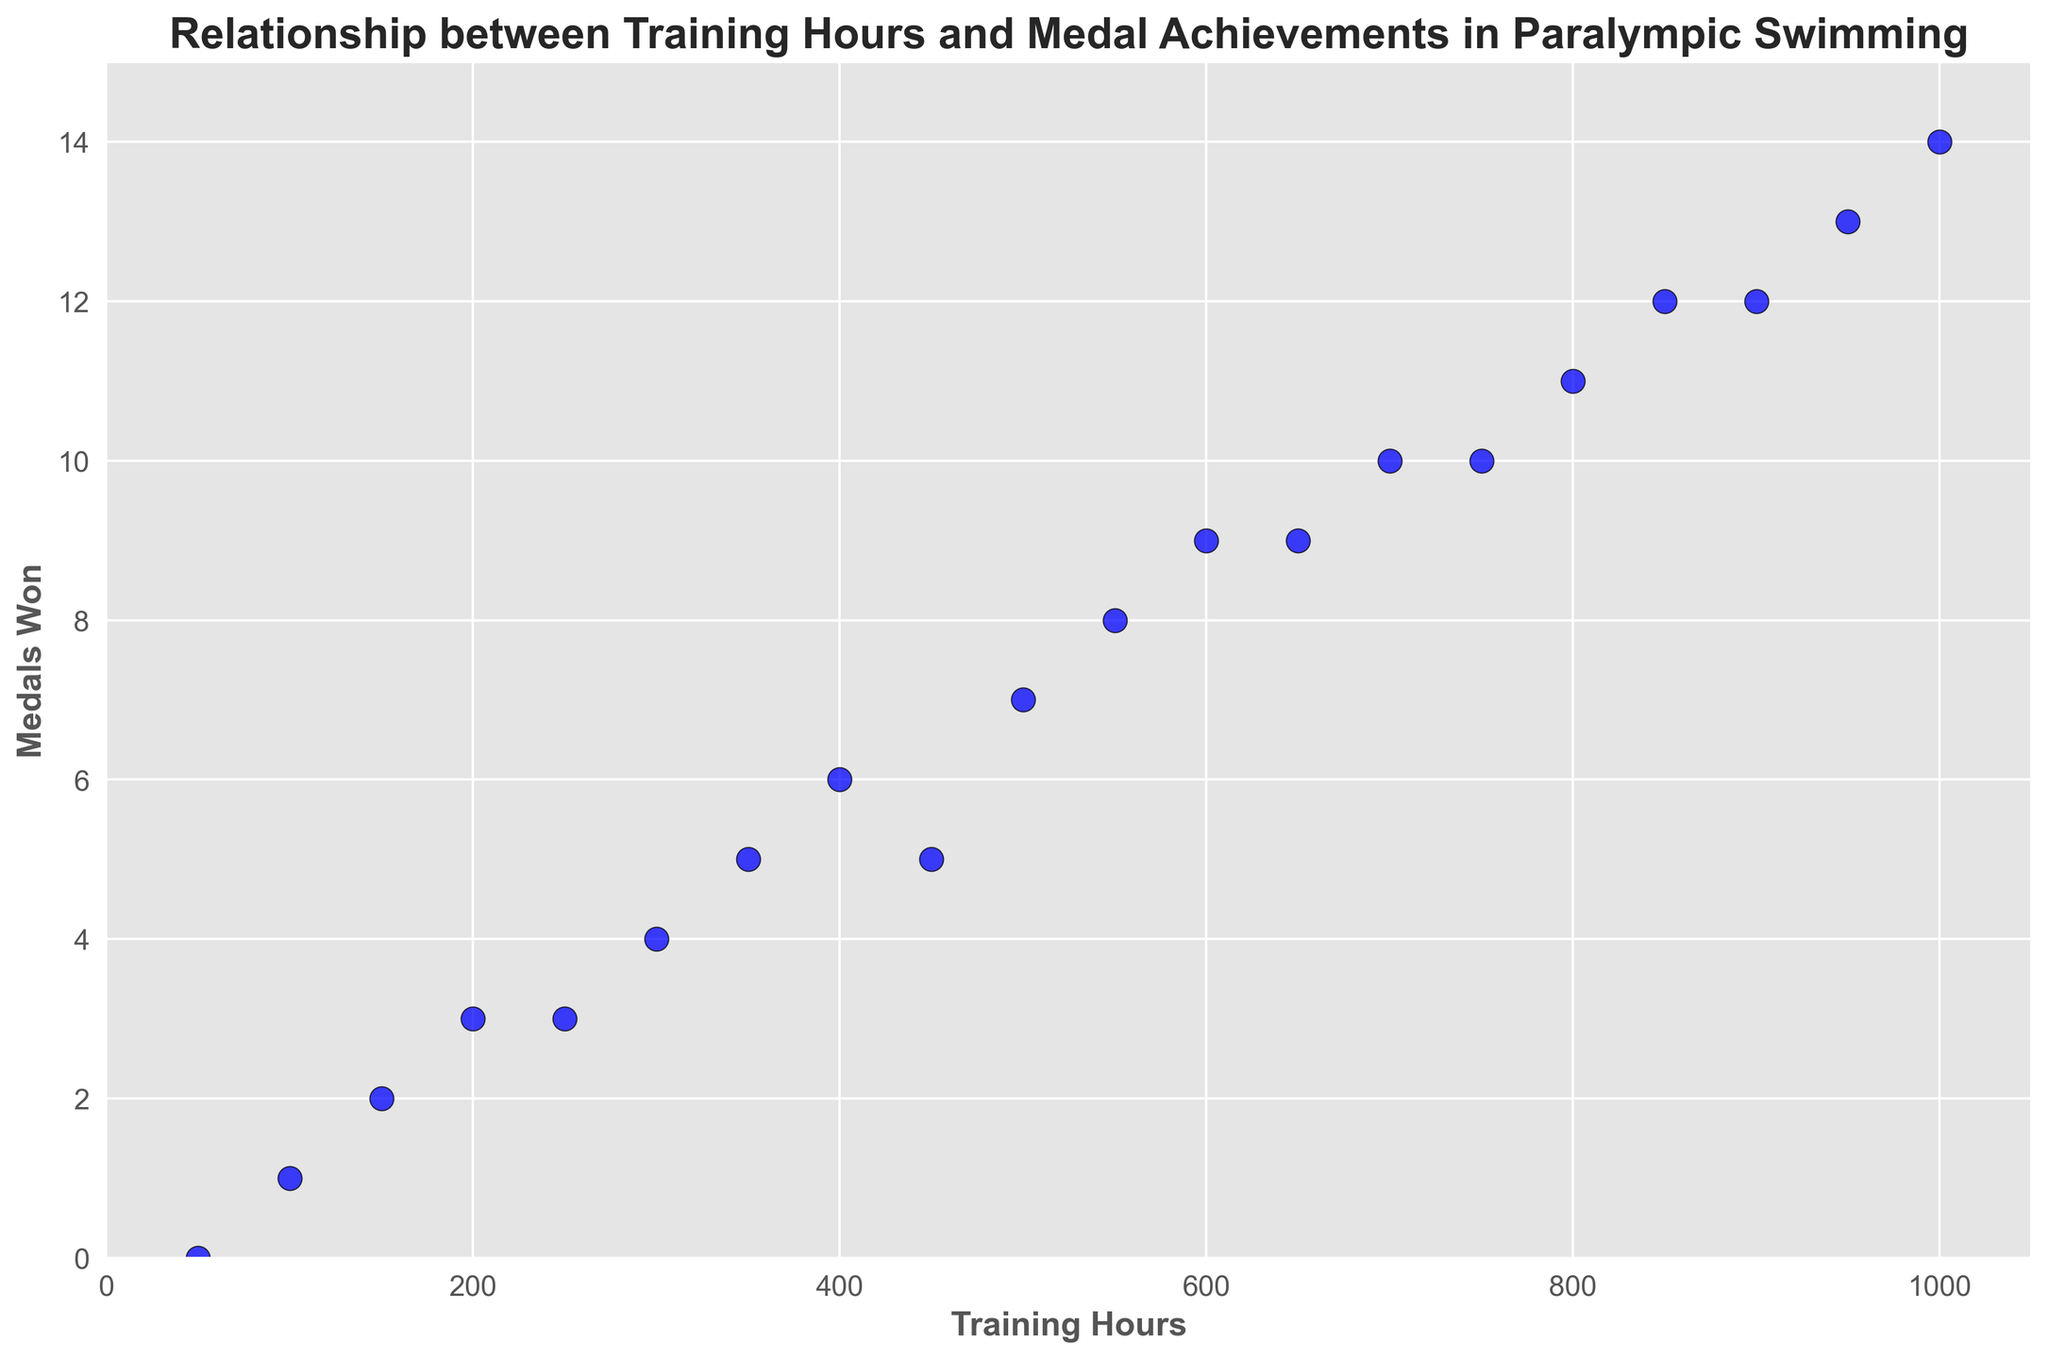what's the average number of medals won for athletes who trained between 100 and 400 hours? To find the average number of medals won, sum the medals for athletes with training hours between 100 and 400 (1, 3, 2, 4, 5, and 6) which totals 21, then divide by the number of athletes in that range (6). So, the average is 21/6 = 3.5
Answer: 3.5 How many more medals did the athlete with 1000 training hours win compared to the athlete with 600 training hours? The athlete with 1000 training hours won 14 medals, while the athlete with 600 training hours won 9 medals. The difference is 14 - 9 = 5 medals.
Answer: 5 Which athlete won more medals, the one with 750 training hours or the one with 850 training hours? The athlete with 750 training hours won 10 medals, while the athlete with 850 training hours won 12 medals. Therefore, the athlete with 850 training hours won more medals.
Answer: 850 training hours What’s the ratio of medals won by the athlete with 900 training hours to the athlete with 450 training hours? The athlete with 900 training hours won 12 medals, and the athlete with 450 training hours won 5 medals. The ratio is therefore 12:5.
Answer: 12:5 Is there a clear linear relationship between training hours and medals won? Observing the scatter plot, each increase in training hours typically correlates with an increase in medals won, indicating a strong positive linear relationship.
Answer: Yes How much did the number of medals increase from 200 training hours to 500 training hours? The athlete with 200 training hours won 3 medals, and the athlete with 500 training hours won 7 medals. The increase is 7 - 3 = 4 medals.
Answer: 4 Which athlete had the highest number of training hours but did not win the highest number of medals? The athlete with the most training hours is 1000, but this athlete did not win the most medals. The highest number of medals was 14, but it was tied with the athlete at 950 training hours.
Answer: Athlete with 1000 training hours Compare the number of medals won by athletes who trained 200 hours and 550 hours. The athlete with 200 training hours won 3 medals, and the athlete with 550 training hours won 8 medals. The athlete with 550 training hours won more medals.
Answer: 550 training hours What's the difference in training hours between the athlete who won 9 medals and the athlete who won 6 medals? The athlete with 9 medals trained for 600 and 650 hours, and the athlete with 6 medals trained for 400 hours. The smallest difference is 600 - 400 = 200 hours.
Answer: 200 Describe the trend you see in the scatter plot. The plot shows a clear upward trend; as training hours increase, the number of medals won also increases, suggesting a positive relationship between these variables.
Answer: Positive trend 